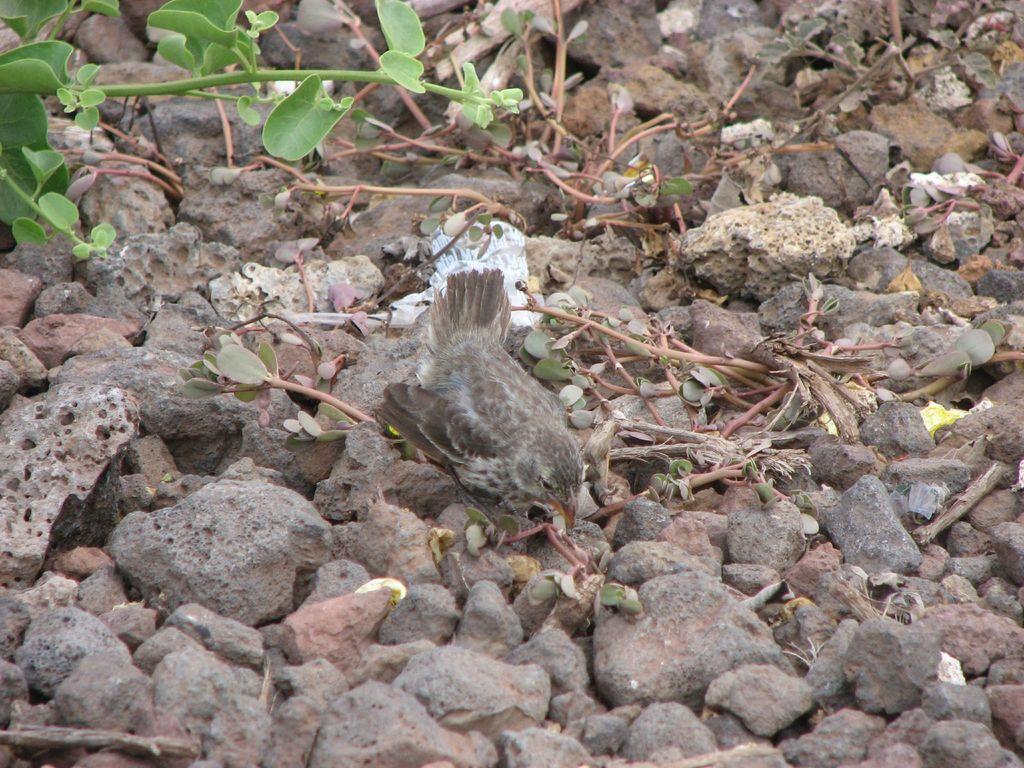Can you describe this image briefly? Here we can see a bird. There are stones and leaves. 